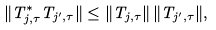<formula> <loc_0><loc_0><loc_500><loc_500>\| T _ { j , \tau } ^ { * } T _ { j ^ { \prime } , \tau } \| \leq \| T _ { j , \tau } \| \, \| T _ { j ^ { \prime } , \tau } \| ,</formula> 